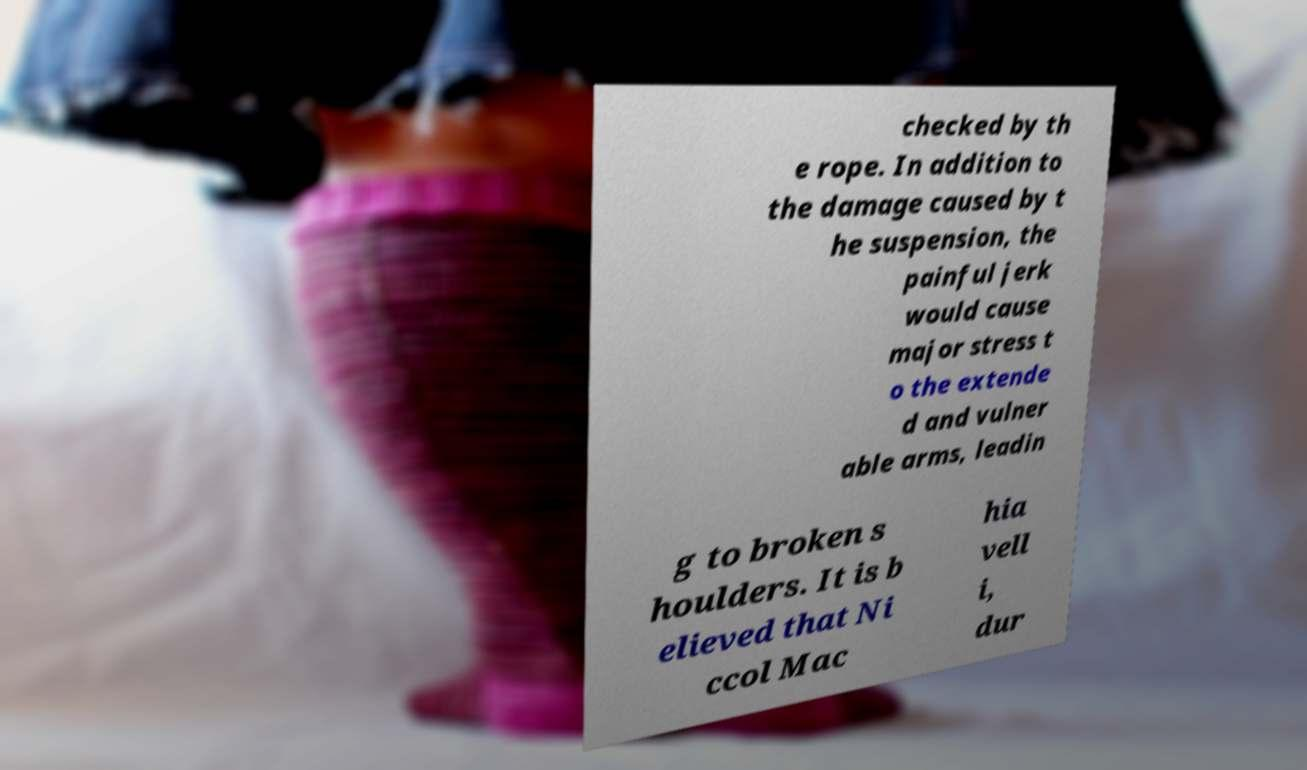I need the written content from this picture converted into text. Can you do that? checked by th e rope. In addition to the damage caused by t he suspension, the painful jerk would cause major stress t o the extende d and vulner able arms, leadin g to broken s houlders. It is b elieved that Ni ccol Mac hia vell i, dur 